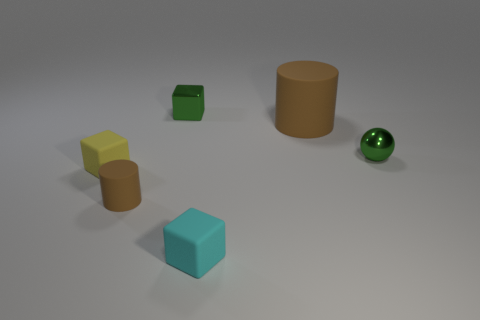Which object appears to be the largest? The large cylinder appears to be the largest object in the image due to its height and circumference. Can you estimate the size of the cylinder relative to the other objects? While an exact size comparison is challenging without specific measurements, the cylinder seems to be approximately twice the height of the cube and roughly three to four times taller than the small cylinder. 